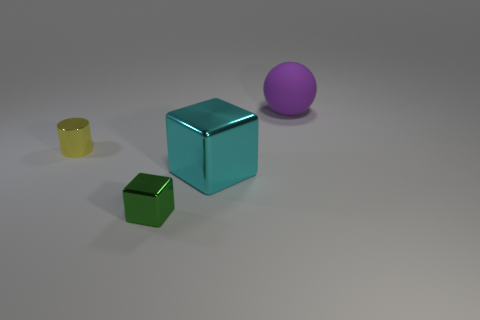Add 4 large cubes. How many objects exist? 8 Subtract all balls. How many objects are left? 3 Add 3 large metallic cubes. How many large metallic cubes exist? 4 Subtract 0 red balls. How many objects are left? 4 Subtract all green metallic blocks. Subtract all shiny cubes. How many objects are left? 1 Add 3 small yellow things. How many small yellow things are left? 4 